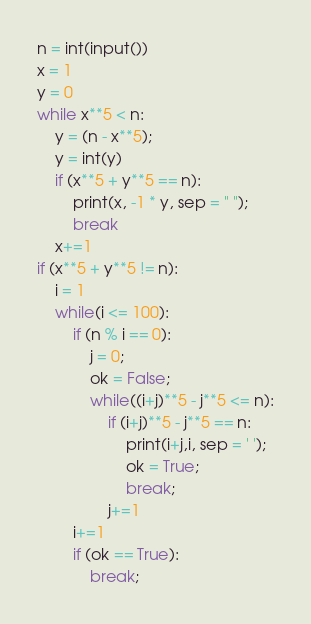Convert code to text. <code><loc_0><loc_0><loc_500><loc_500><_Python_>n = int(input())
x = 1
y = 0
while x**5 < n:
	y = (n - x**5);
	y = int(y)
	if (x**5 + y**5 == n):
		print(x, -1 * y, sep = " ");
		break
	x+=1
if (x**5 + y**5 != n):
	i = 1
	while(i <= 100):
		if (n % i == 0):
			j = 0;
			ok = False;
			while((i+j)**5 - j**5 <= n):
				if (i+j)**5 - j**5 == n:
					print(i+j,i, sep = ' ');
					ok = True;
					break;
				j+=1
		i+=1
		if (ok == True):
			break;</code> 